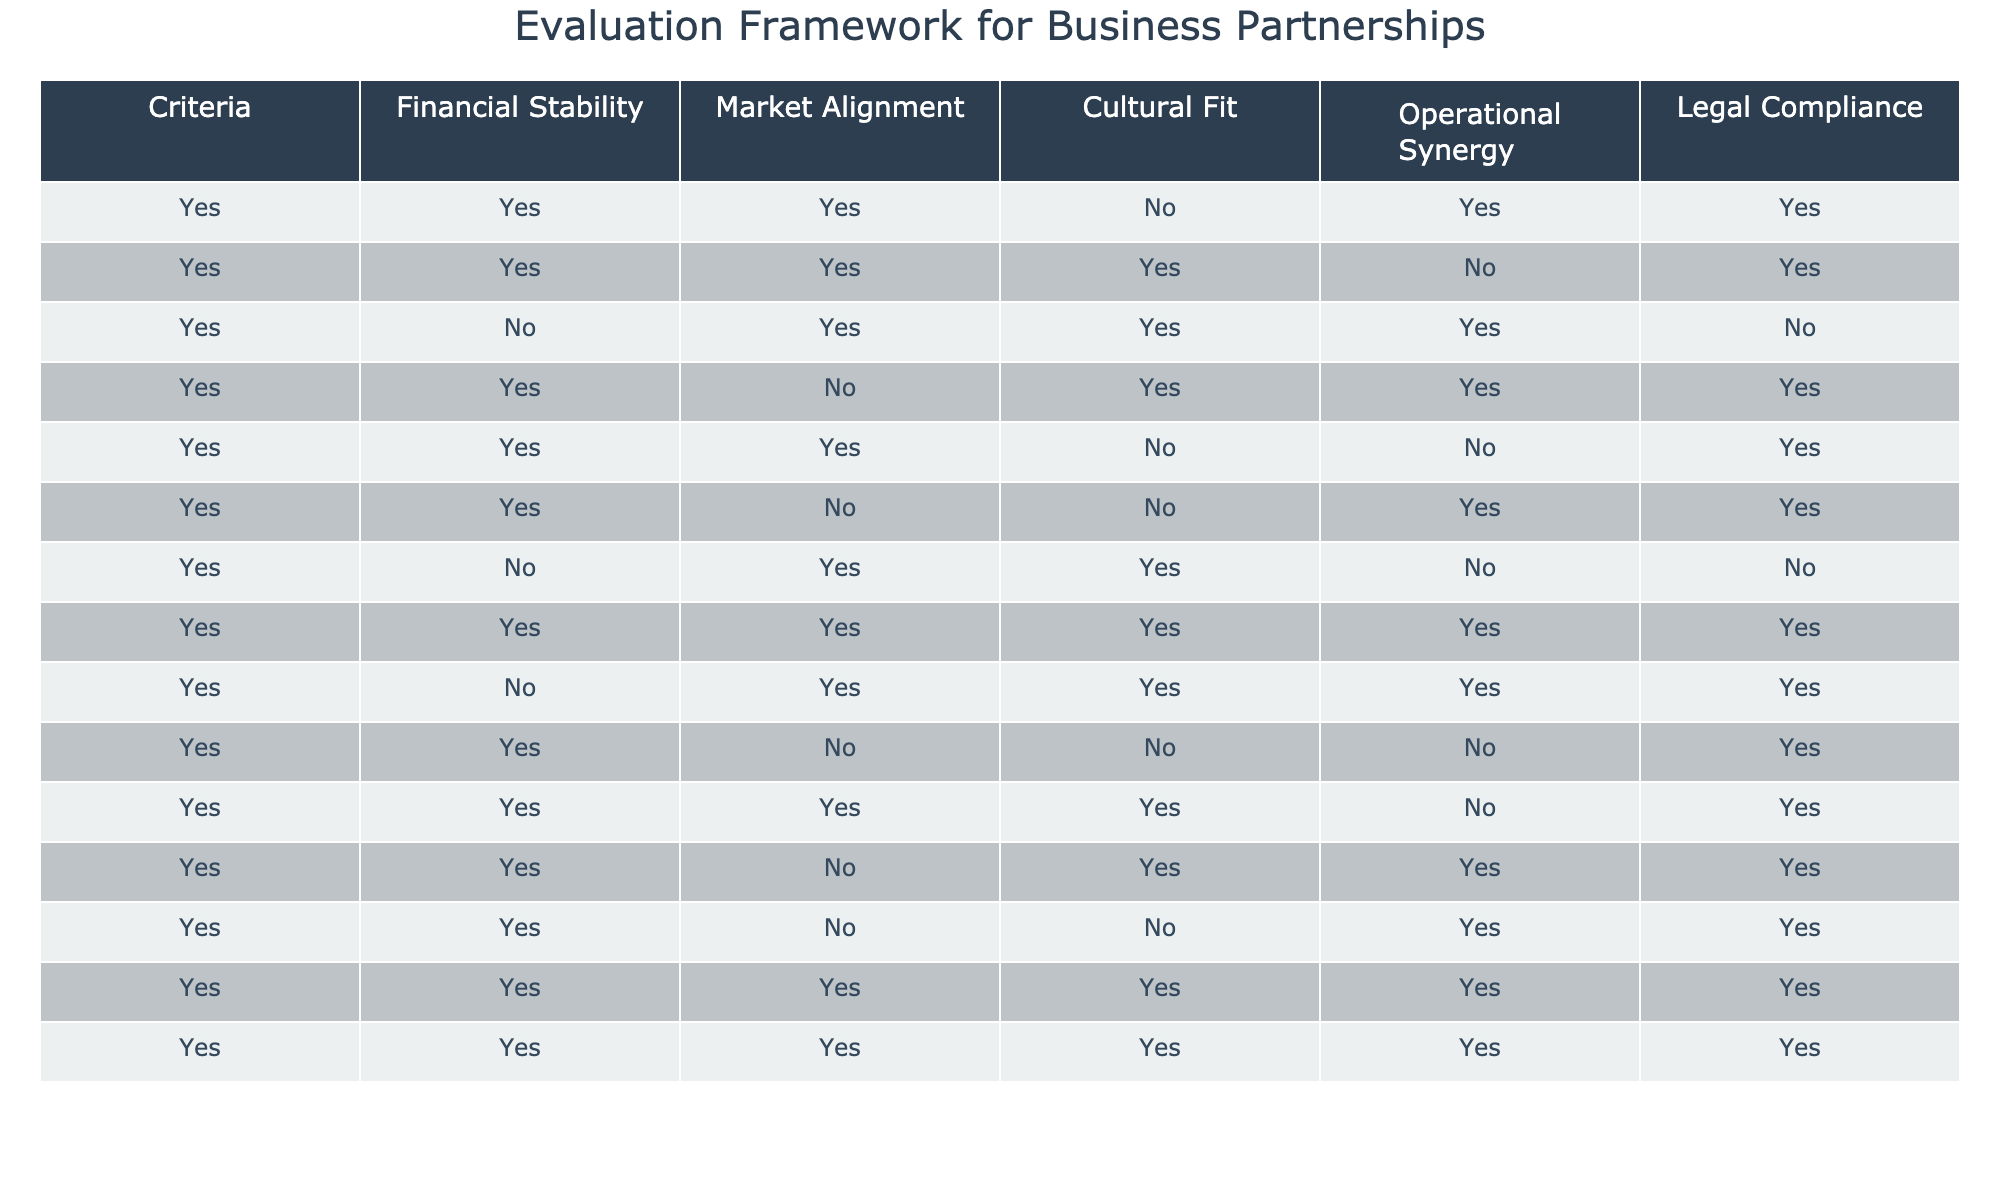What is the financial stability status of Airbnb? Looking at the row for Airbnb, the financial stability criteria is marked as False. This means that, according to the data, Airbnb does not have financial stability.
Answer: No Which companies have both market alignment and operational synergy? To find the companies with both market alignment (True) and operational synergy (True), I checked each company's row. The companies that meet both criteria are Johnson & Johnson, Siemens, and Procter & Gamble.
Answer: Johnson & Johnson, Siemens, Procter & Gamble What percentage of the companies in the table are culturally fit? There are 15 companies in total. The culturally fit companies are Salesforce, Airbnb, Siemens, Cisco Systems, Nike, and Amazon. This gives us a total of 6 companies. Therefore, the percentage is (6/15)*100 = 40%.
Answer: 40% Which company has the lowest number of 'Yes' responses across all criteria? By reviewing the entire table, the company with the lowest number of Yes responses is Airbnb, with 3 Yeses out of 5 criteria (market alignment, operational synergy) while failing in financial stability and legal compliance, with only cultural fit marked as Yes.
Answer: Airbnb Is Tesla legally compliant? In the row for Tesla, the legal compliance status is marked as True. This indicates that Tesla is legally compliant according to the table data.
Answer: Yes How many companies are both financially stable and culturally fit? To find this, I need to count how many companies have both financial stability marked as True and cultural fit marked as True. Reviewing the table, the companies that fit this criteria are Salesforce, Procter & Gamble, Nike, and Microsoft. In total, there are 4 such companies.
Answer: 4 What is the average number of 'Yes' responses for companies that are operationally synergistic? To determine this, I first filter the companies that have operational synergy marked as True. These companies are Johnson & Johnson, Airbnb, Siemens, and Cisco Systems. Next, I count the Yes responses for these companies and find their average. Johnson & Johnson has 4 Yeses, Airbnb has 3, Siemens has 4, and Cisco Systems has 4, leading us to the average: (4+3+4+4)/4 = 3.75.
Answer: 3.75 Which companies are not financially stable and have legal compliance? Checking for companies that have False for financial stability and True for legal compliance yields Uber and Airbnb according to the table data.
Answer: Uber, Airbnb 